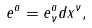Convert formula to latex. <formula><loc_0><loc_0><loc_500><loc_500>e ^ { a } = e _ { \nu } ^ { a } d x ^ { \nu } ,</formula> 